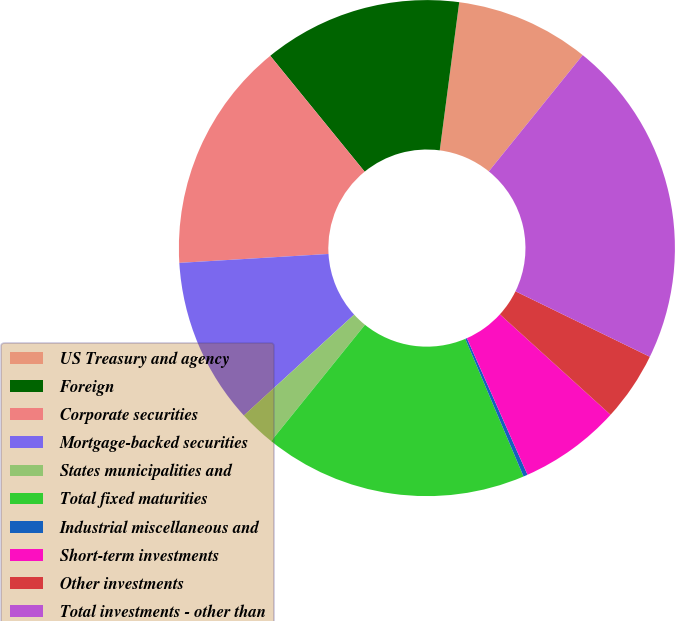<chart> <loc_0><loc_0><loc_500><loc_500><pie_chart><fcel>US Treasury and agency<fcel>Foreign<fcel>Corporate securities<fcel>Mortgage-backed securities<fcel>States municipalities and<fcel>Total fixed maturities<fcel>Industrial miscellaneous and<fcel>Short-term investments<fcel>Other investments<fcel>Total investments - other than<nl><fcel>8.73%<fcel>12.96%<fcel>15.07%<fcel>10.84%<fcel>2.4%<fcel>17.18%<fcel>0.28%<fcel>6.62%<fcel>4.51%<fcel>21.41%<nl></chart> 